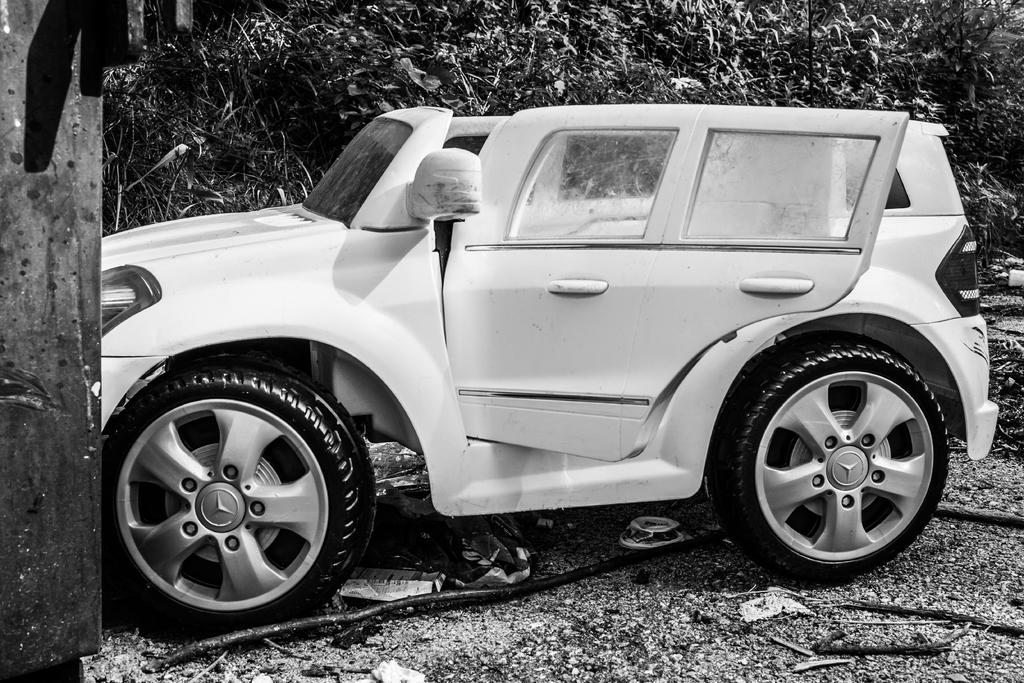What is the color of the vehicle in the image? The vehicle in the image is white. What is the position of the vehicle's door? The vehicle's door is opened. Where is the vehicle located in the image? The vehicle is on the ground. What is present on the ground near the vehicle? There is a cable and some sticks on the ground near the vehicle. What can be seen in the background of the image? There are trees in the background of the image. What is the interest rate of the loan taken for the vehicle in the image? There is no information about a loan or interest rate in the image; it only shows a vehicle with an opened door. 